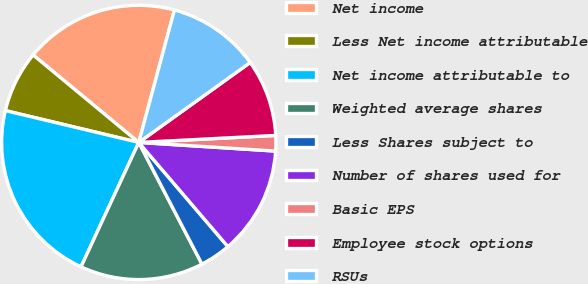Convert chart. <chart><loc_0><loc_0><loc_500><loc_500><pie_chart><fcel>Net income<fcel>Less Net income attributable<fcel>Net income attributable to<fcel>Weighted average shares<fcel>Less Shares subject to<fcel>Number of shares used for<fcel>Basic EPS<fcel>Employee stock options<fcel>RSUs<nl><fcel>18.18%<fcel>7.28%<fcel>21.81%<fcel>14.54%<fcel>3.64%<fcel>12.73%<fcel>1.82%<fcel>9.09%<fcel>10.91%<nl></chart> 